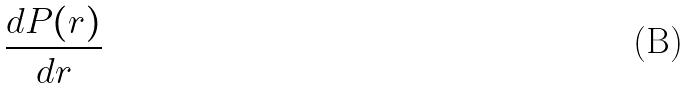<formula> <loc_0><loc_0><loc_500><loc_500>\frac { d P ( r ) } { d r }</formula> 